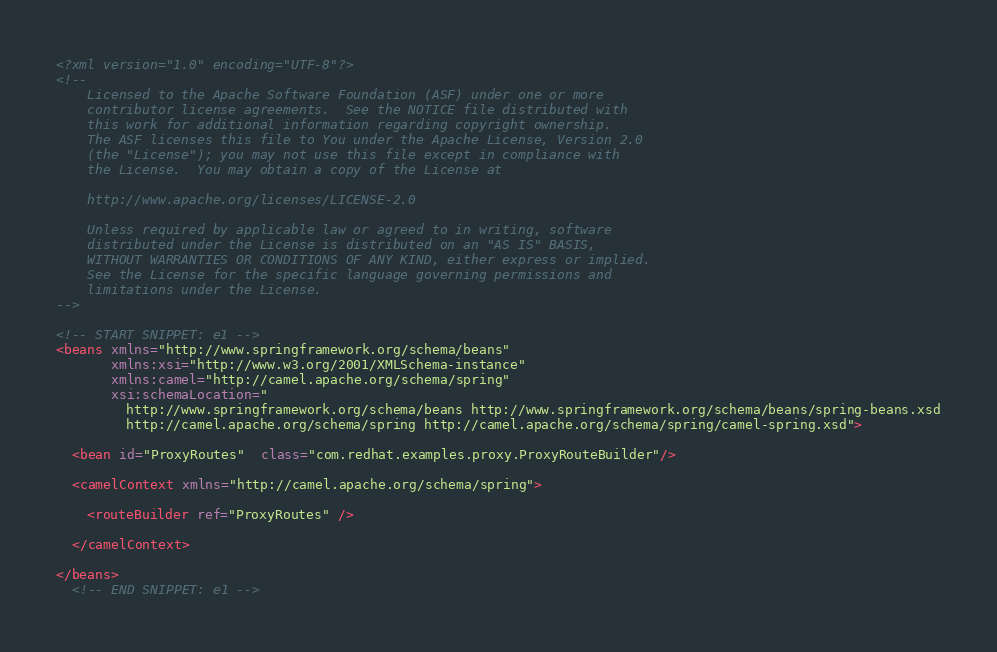<code> <loc_0><loc_0><loc_500><loc_500><_XML_><?xml version="1.0" encoding="UTF-8"?>
<!--
    Licensed to the Apache Software Foundation (ASF) under one or more
    contributor license agreements.  See the NOTICE file distributed with
    this work for additional information regarding copyright ownership.
    The ASF licenses this file to You under the Apache License, Version 2.0
    (the "License"); you may not use this file except in compliance with
    the License.  You may obtain a copy of the License at

    http://www.apache.org/licenses/LICENSE-2.0

    Unless required by applicable law or agreed to in writing, software
    distributed under the License is distributed on an "AS IS" BASIS,
    WITHOUT WARRANTIES OR CONDITIONS OF ANY KIND, either express or implied.
    See the License for the specific language governing permissions and
    limitations under the License.
-->

<!-- START SNIPPET: e1 -->
<beans xmlns="http://www.springframework.org/schema/beans"
       xmlns:xsi="http://www.w3.org/2001/XMLSchema-instance"
       xmlns:camel="http://camel.apache.org/schema/spring"
       xsi:schemaLocation="
         http://www.springframework.org/schema/beans http://www.springframework.org/schema/beans/spring-beans.xsd
         http://camel.apache.org/schema/spring http://camel.apache.org/schema/spring/camel-spring.xsd">

  <bean id="ProxyRoutes"  class="com.redhat.examples.proxy.ProxyRouteBuilder"/>

  <camelContext xmlns="http://camel.apache.org/schema/spring">

    <routeBuilder ref="ProxyRoutes" />

  </camelContext>

</beans>
  <!-- END SNIPPET: e1 --></code> 